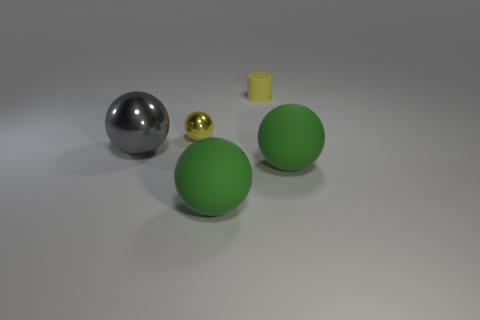Subtract all yellow spheres. How many spheres are left? 3 Subtract all big metal spheres. How many spheres are left? 3 Add 5 tiny red metal cylinders. How many objects exist? 10 Subtract all purple spheres. Subtract all red cubes. How many spheres are left? 4 Subtract all spheres. How many objects are left? 1 Add 2 tiny gray matte cylinders. How many tiny gray matte cylinders exist? 2 Subtract 0 gray cylinders. How many objects are left? 5 Subtract all cylinders. Subtract all yellow objects. How many objects are left? 2 Add 2 big gray metal objects. How many big gray metal objects are left? 3 